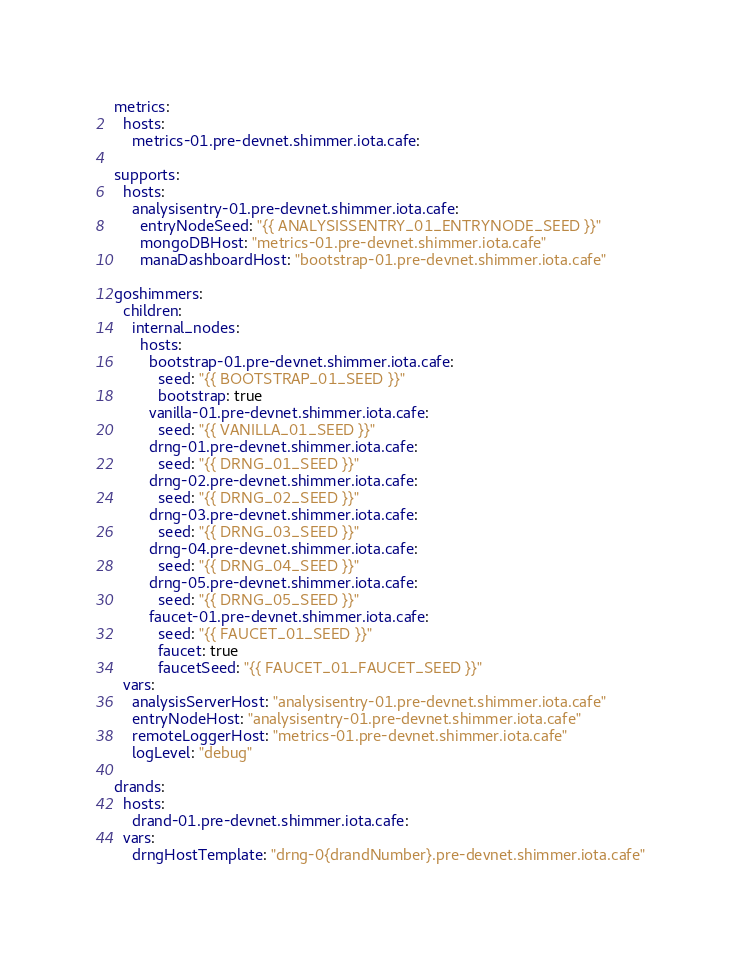<code> <loc_0><loc_0><loc_500><loc_500><_YAML_>metrics:
  hosts:
    metrics-01.pre-devnet.shimmer.iota.cafe:

supports:
  hosts:
    analysisentry-01.pre-devnet.shimmer.iota.cafe:
      entryNodeSeed: "{{ ANALYSISSENTRY_01_ENTRYNODE_SEED }}"
      mongoDBHost: "metrics-01.pre-devnet.shimmer.iota.cafe"
      manaDashboardHost: "bootstrap-01.pre-devnet.shimmer.iota.cafe"

goshimmers:
  children:
    internal_nodes:
      hosts:
        bootstrap-01.pre-devnet.shimmer.iota.cafe:
          seed: "{{ BOOTSTRAP_01_SEED }}"
          bootstrap: true
        vanilla-01.pre-devnet.shimmer.iota.cafe:
          seed: "{{ VANILLA_01_SEED }}"
        drng-01.pre-devnet.shimmer.iota.cafe:
          seed: "{{ DRNG_01_SEED }}"
        drng-02.pre-devnet.shimmer.iota.cafe:
          seed: "{{ DRNG_02_SEED }}"
        drng-03.pre-devnet.shimmer.iota.cafe:
          seed: "{{ DRNG_03_SEED }}"
        drng-04.pre-devnet.shimmer.iota.cafe:
          seed: "{{ DRNG_04_SEED }}"
        drng-05.pre-devnet.shimmer.iota.cafe:
          seed: "{{ DRNG_05_SEED }}"
        faucet-01.pre-devnet.shimmer.iota.cafe:
          seed: "{{ FAUCET_01_SEED }}"
          faucet: true
          faucetSeed: "{{ FAUCET_01_FAUCET_SEED }}"
  vars:
    analysisServerHost: "analysisentry-01.pre-devnet.shimmer.iota.cafe"
    entryNodeHost: "analysisentry-01.pre-devnet.shimmer.iota.cafe"
    remoteLoggerHost: "metrics-01.pre-devnet.shimmer.iota.cafe"
    logLevel: "debug"

drands:
  hosts:
    drand-01.pre-devnet.shimmer.iota.cafe:
  vars:
    drngHostTemplate: "drng-0{drandNumber}.pre-devnet.shimmer.iota.cafe"
</code> 